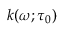Convert formula to latex. <formula><loc_0><loc_0><loc_500><loc_500>k ( \omega ; \tau _ { 0 } )</formula> 